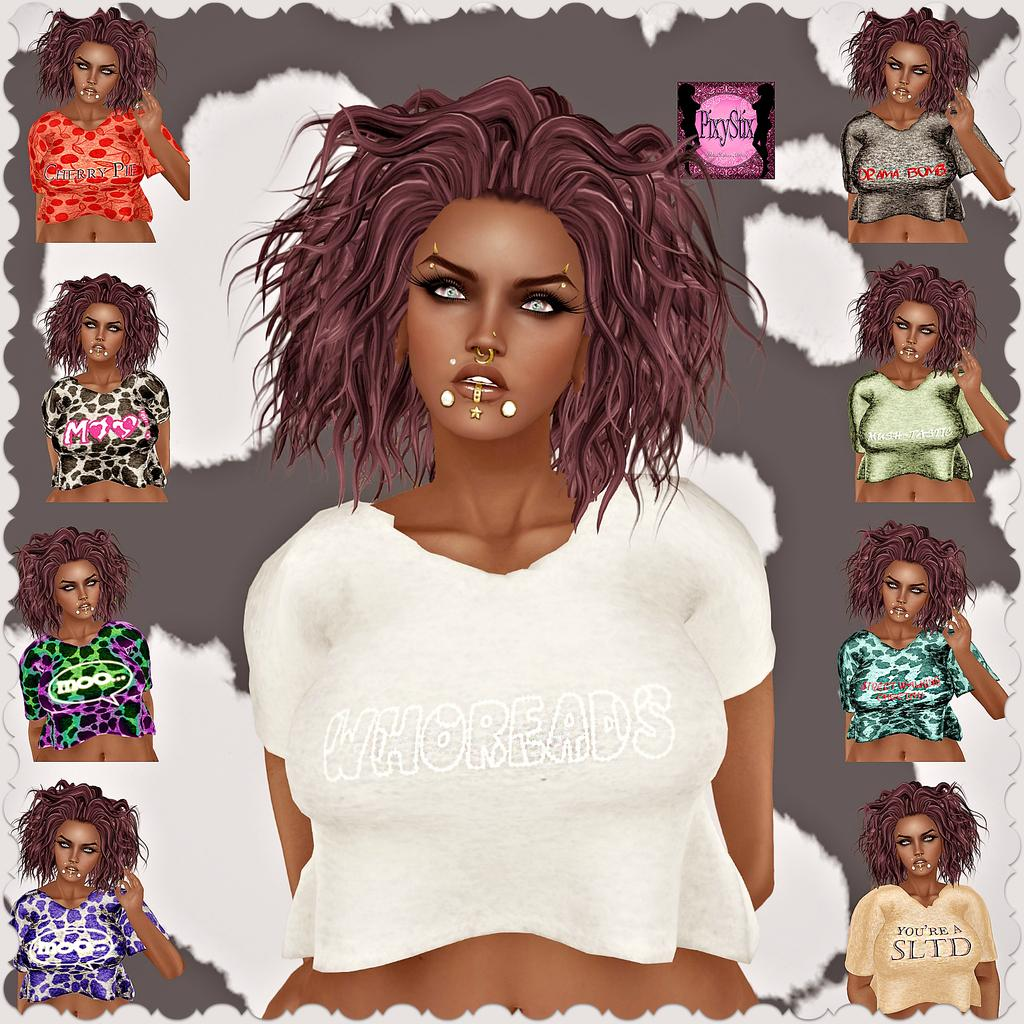What object is present in the image that typically holds a photograph? There is a photo frame in the image. What is depicted inside the photo frame? The photo frame contains a group of cartoon images. Can you describe the subjects of the cartoon images? The cartoon images are of girls. How deep is the ocean in the image? There is no ocean present in the image; it features a photo frame with cartoon images of girls. How many seats are visible in the image? There are no seats visible in the image; it features a photo frame with cartoon images of girls. 